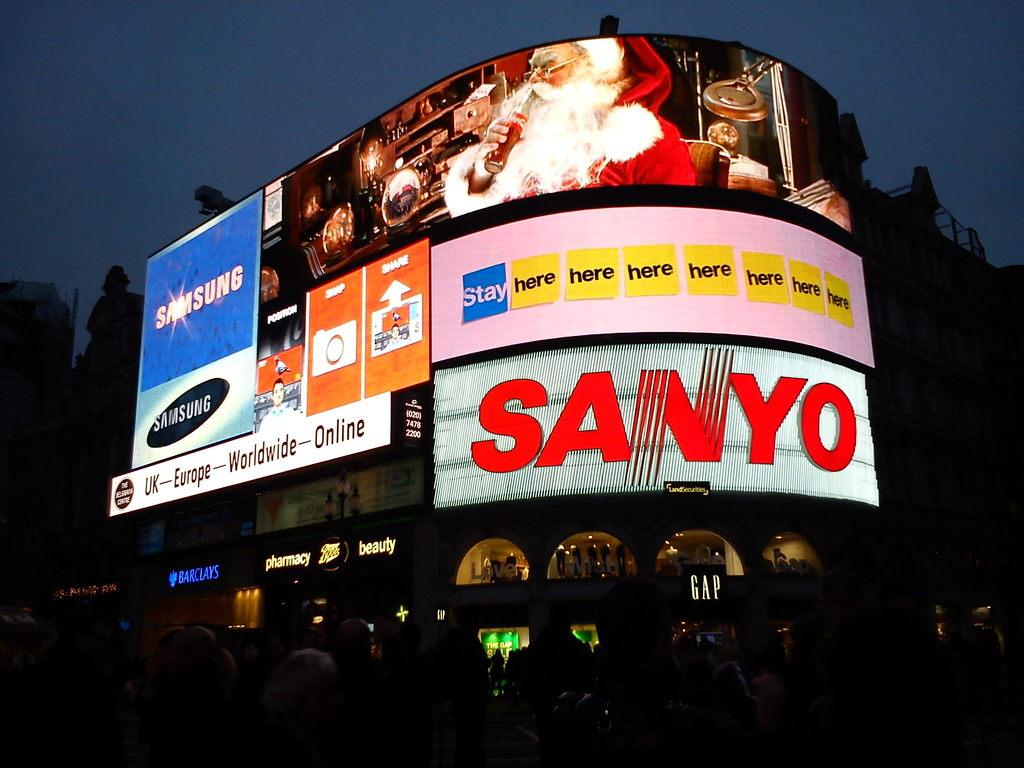<image>
Share a concise interpretation of the image provided. A building with large advertisements for Sanyo and Samsung. 